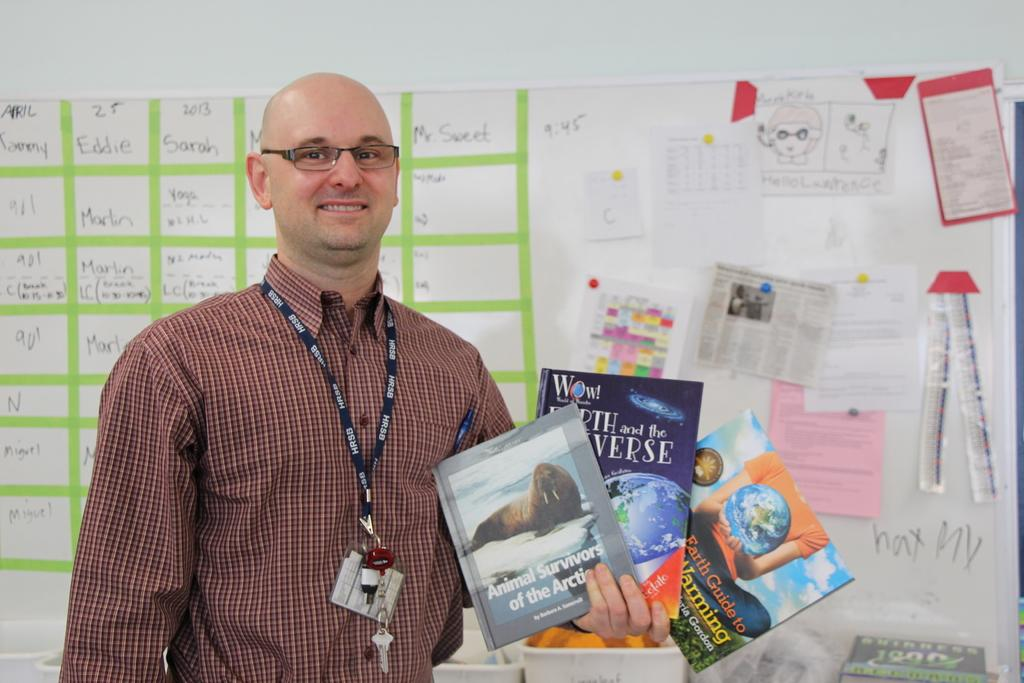Where is the man located in the image? The man is standing in the bottom left side of the image. What is the man holding in the image? The man is holding some books. What is behind the man in the image? There is a wall behind the man. What is on the wall behind the man? There is a board and posters on the wall. Is the man wearing a mask in the image? There is no mention of a mask in the image, so we cannot determine if the man is wearing one. 